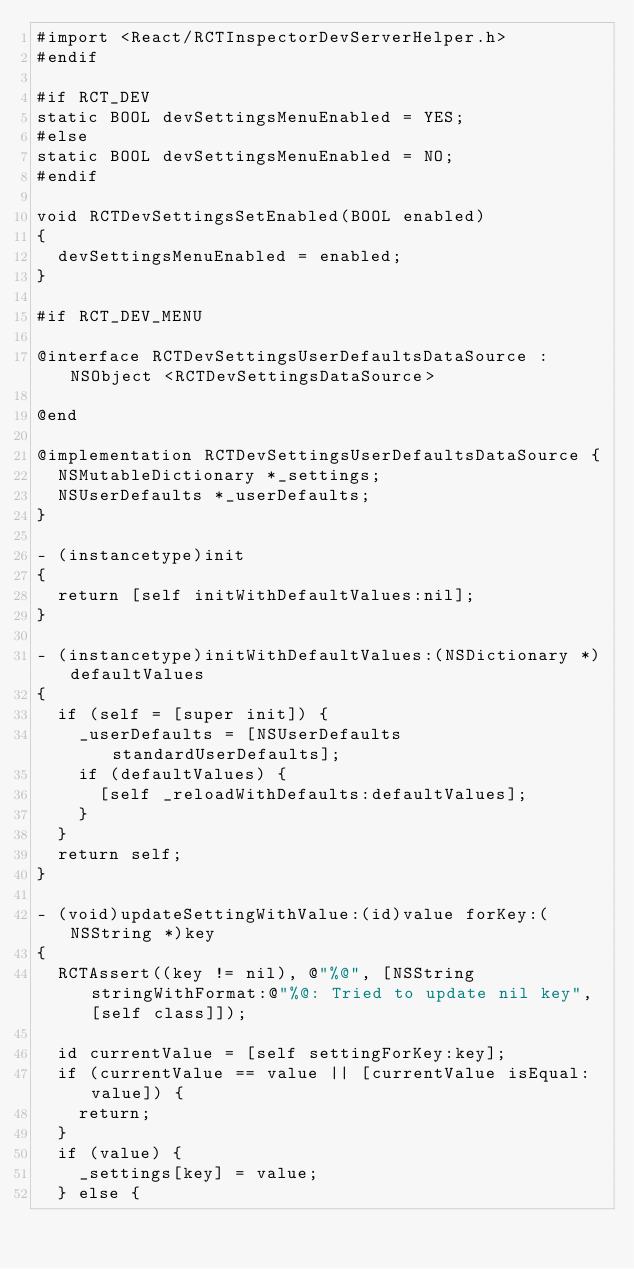<code> <loc_0><loc_0><loc_500><loc_500><_ObjectiveC_>#import <React/RCTInspectorDevServerHelper.h>
#endif

#if RCT_DEV
static BOOL devSettingsMenuEnabled = YES;
#else
static BOOL devSettingsMenuEnabled = NO;
#endif

void RCTDevSettingsSetEnabled(BOOL enabled)
{
  devSettingsMenuEnabled = enabled;
}

#if RCT_DEV_MENU

@interface RCTDevSettingsUserDefaultsDataSource : NSObject <RCTDevSettingsDataSource>

@end

@implementation RCTDevSettingsUserDefaultsDataSource {
  NSMutableDictionary *_settings;
  NSUserDefaults *_userDefaults;
}

- (instancetype)init
{
  return [self initWithDefaultValues:nil];
}

- (instancetype)initWithDefaultValues:(NSDictionary *)defaultValues
{
  if (self = [super init]) {
    _userDefaults = [NSUserDefaults standardUserDefaults];
    if (defaultValues) {
      [self _reloadWithDefaults:defaultValues];
    }
  }
  return self;
}

- (void)updateSettingWithValue:(id)value forKey:(NSString *)key
{
  RCTAssert((key != nil), @"%@", [NSString stringWithFormat:@"%@: Tried to update nil key", [self class]]);

  id currentValue = [self settingForKey:key];
  if (currentValue == value || [currentValue isEqual:value]) {
    return;
  }
  if (value) {
    _settings[key] = value;
  } else {</code> 